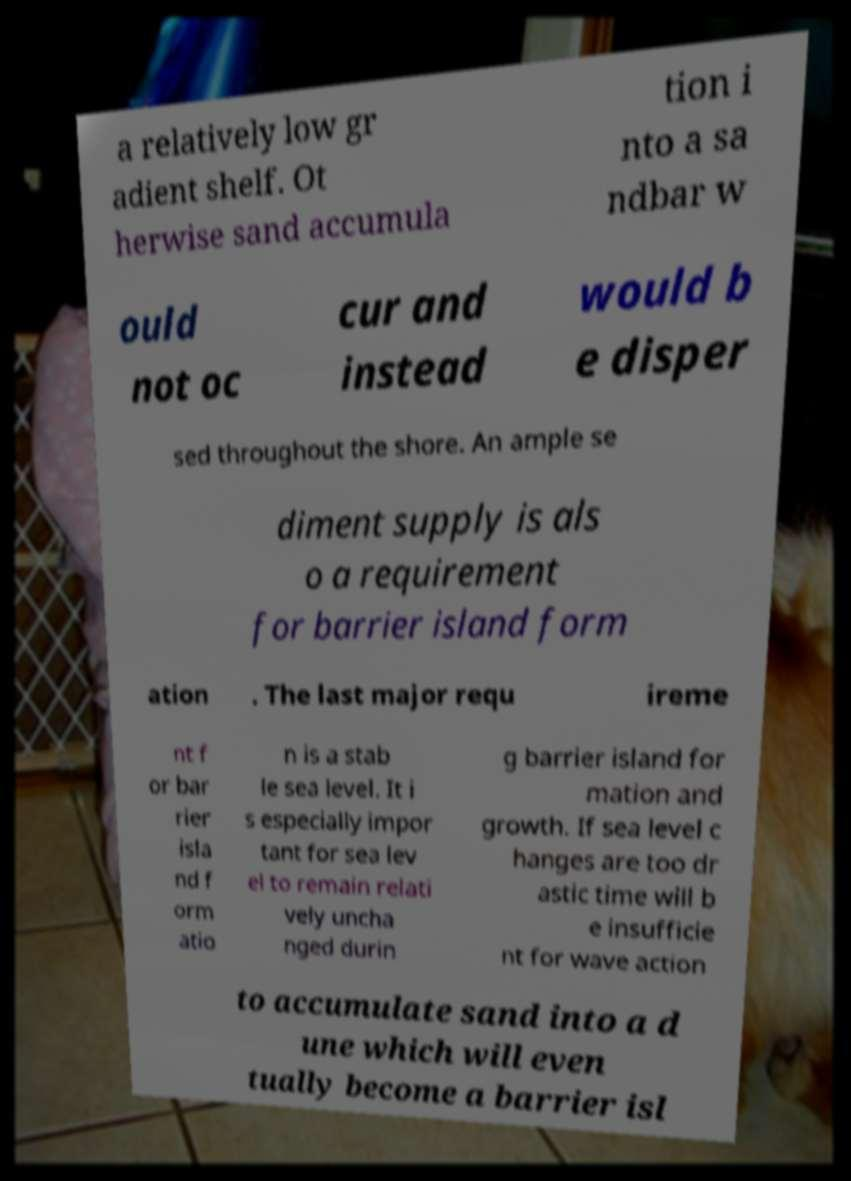Can you read and provide the text displayed in the image?This photo seems to have some interesting text. Can you extract and type it out for me? a relatively low gr adient shelf. Ot herwise sand accumula tion i nto a sa ndbar w ould not oc cur and instead would b e disper sed throughout the shore. An ample se diment supply is als o a requirement for barrier island form ation . The last major requ ireme nt f or bar rier isla nd f orm atio n is a stab le sea level. It i s especially impor tant for sea lev el to remain relati vely uncha nged durin g barrier island for mation and growth. If sea level c hanges are too dr astic time will b e insufficie nt for wave action to accumulate sand into a d une which will even tually become a barrier isl 